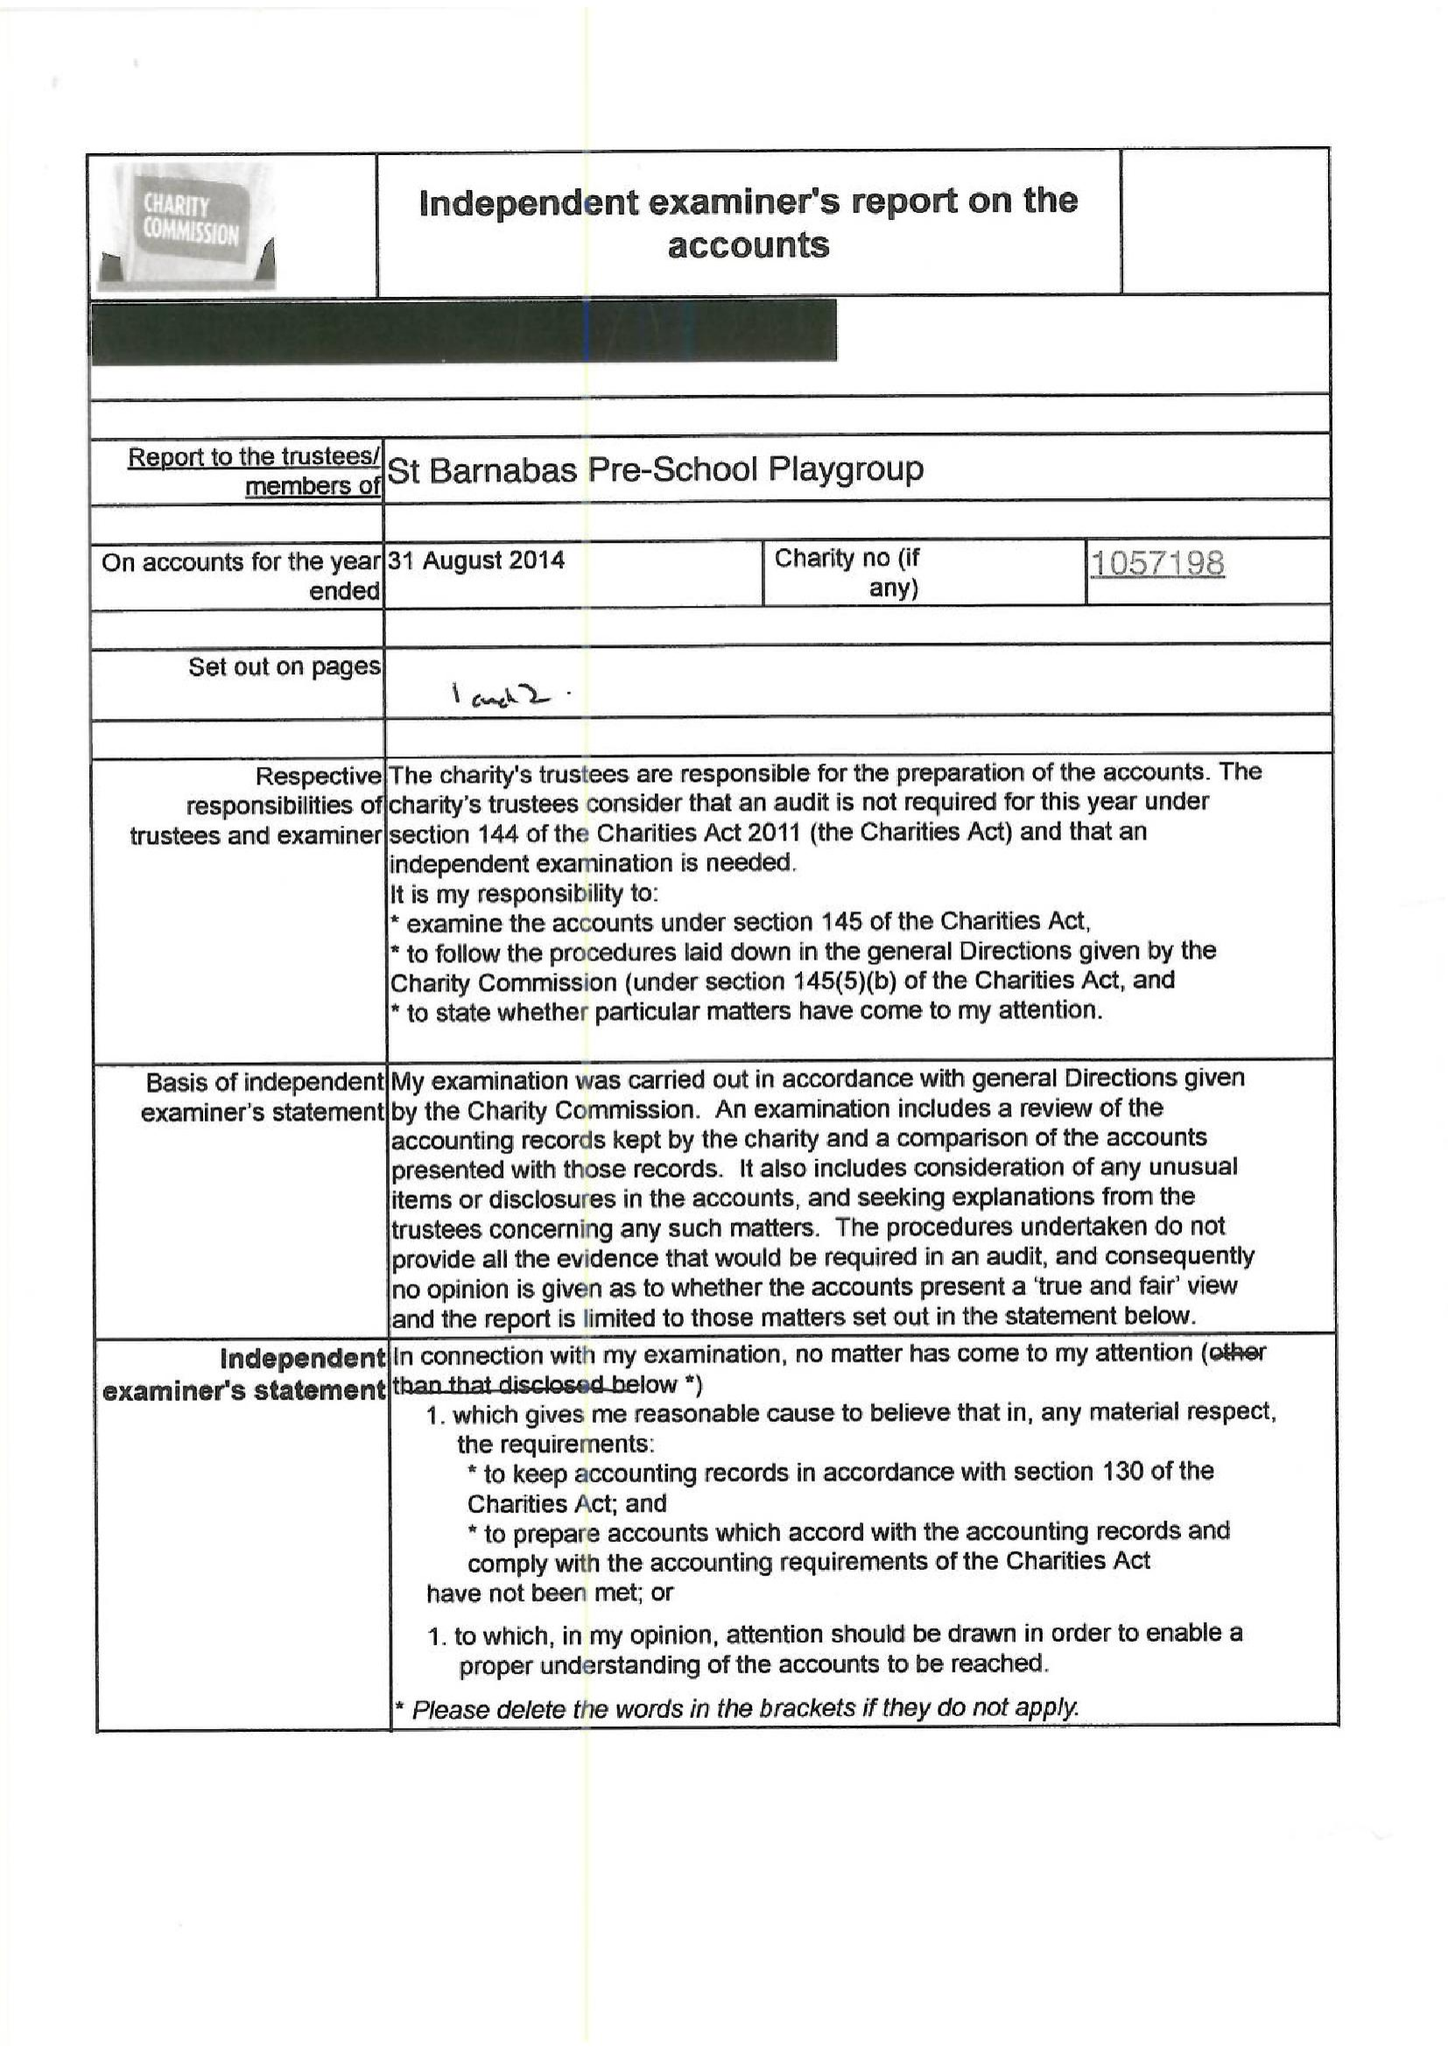What is the value for the address__street_line?
Answer the question using a single word or phrase. PITSHANGER LANE 